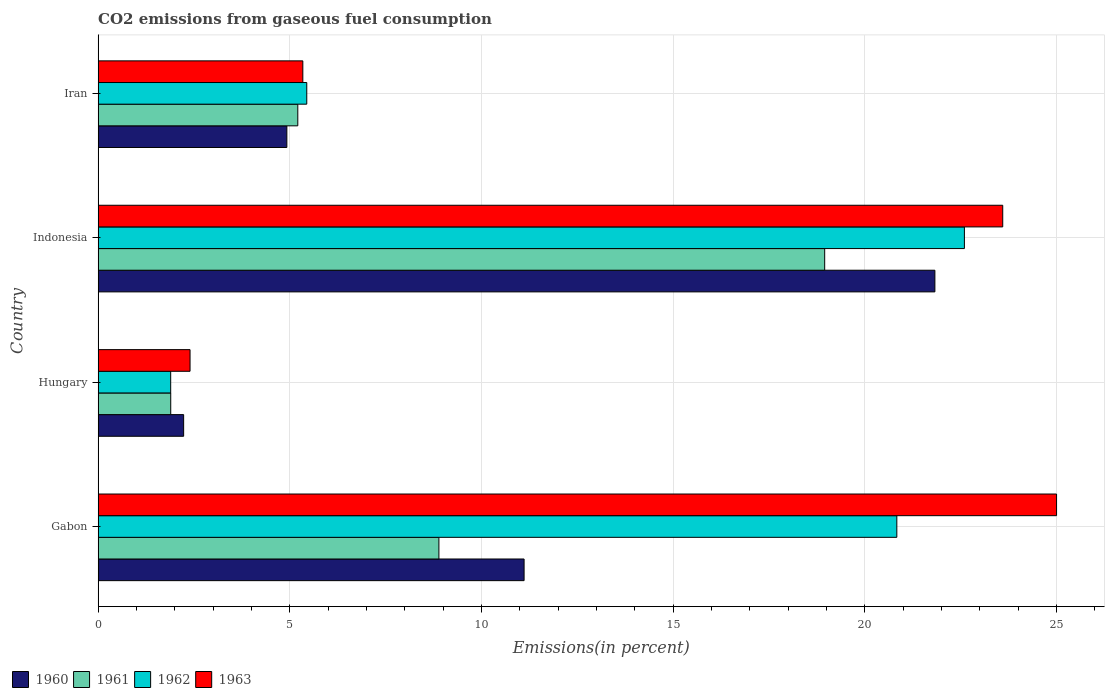How many different coloured bars are there?
Keep it short and to the point. 4. Are the number of bars per tick equal to the number of legend labels?
Your answer should be compact. Yes. Are the number of bars on each tick of the Y-axis equal?
Offer a very short reply. Yes. How many bars are there on the 4th tick from the top?
Your answer should be compact. 4. What is the label of the 3rd group of bars from the top?
Provide a short and direct response. Hungary. In how many cases, is the number of bars for a given country not equal to the number of legend labels?
Make the answer very short. 0. What is the total CO2 emitted in 1961 in Indonesia?
Provide a succinct answer. 18.95. Across all countries, what is the maximum total CO2 emitted in 1961?
Provide a short and direct response. 18.95. Across all countries, what is the minimum total CO2 emitted in 1963?
Make the answer very short. 2.4. In which country was the total CO2 emitted in 1961 maximum?
Provide a succinct answer. Indonesia. In which country was the total CO2 emitted in 1961 minimum?
Your response must be concise. Hungary. What is the total total CO2 emitted in 1962 in the graph?
Keep it short and to the point. 50.76. What is the difference between the total CO2 emitted in 1963 in Indonesia and that in Iran?
Your answer should be very brief. 18.26. What is the difference between the total CO2 emitted in 1961 in Hungary and the total CO2 emitted in 1962 in Iran?
Make the answer very short. -3.55. What is the average total CO2 emitted in 1960 per country?
Provide a short and direct response. 10.02. What is the difference between the total CO2 emitted in 1960 and total CO2 emitted in 1962 in Iran?
Give a very brief answer. -0.52. In how many countries, is the total CO2 emitted in 1960 greater than 1 %?
Make the answer very short. 4. What is the ratio of the total CO2 emitted in 1961 in Indonesia to that in Iran?
Offer a terse response. 3.64. Is the total CO2 emitted in 1961 in Hungary less than that in Iran?
Provide a short and direct response. Yes. What is the difference between the highest and the second highest total CO2 emitted in 1961?
Ensure brevity in your answer.  10.06. What is the difference between the highest and the lowest total CO2 emitted in 1963?
Your answer should be very brief. 22.6. Is the sum of the total CO2 emitted in 1960 in Indonesia and Iran greater than the maximum total CO2 emitted in 1961 across all countries?
Make the answer very short. Yes. Is it the case that in every country, the sum of the total CO2 emitted in 1963 and total CO2 emitted in 1962 is greater than the total CO2 emitted in 1961?
Your answer should be very brief. Yes. How many bars are there?
Provide a short and direct response. 16. Are all the bars in the graph horizontal?
Provide a succinct answer. Yes. How many countries are there in the graph?
Ensure brevity in your answer.  4. What is the difference between two consecutive major ticks on the X-axis?
Your response must be concise. 5. Are the values on the major ticks of X-axis written in scientific E-notation?
Your answer should be very brief. No. Does the graph contain any zero values?
Offer a terse response. No. What is the title of the graph?
Ensure brevity in your answer.  CO2 emissions from gaseous fuel consumption. Does "1990" appear as one of the legend labels in the graph?
Your answer should be very brief. No. What is the label or title of the X-axis?
Ensure brevity in your answer.  Emissions(in percent). What is the Emissions(in percent) in 1960 in Gabon?
Your answer should be very brief. 11.11. What is the Emissions(in percent) of 1961 in Gabon?
Offer a terse response. 8.89. What is the Emissions(in percent) in 1962 in Gabon?
Make the answer very short. 20.83. What is the Emissions(in percent) of 1960 in Hungary?
Offer a terse response. 2.23. What is the Emissions(in percent) of 1961 in Hungary?
Make the answer very short. 1.89. What is the Emissions(in percent) in 1962 in Hungary?
Provide a succinct answer. 1.89. What is the Emissions(in percent) of 1963 in Hungary?
Ensure brevity in your answer.  2.4. What is the Emissions(in percent) in 1960 in Indonesia?
Make the answer very short. 21.83. What is the Emissions(in percent) of 1961 in Indonesia?
Your response must be concise. 18.95. What is the Emissions(in percent) in 1962 in Indonesia?
Your answer should be very brief. 22.6. What is the Emissions(in percent) in 1963 in Indonesia?
Make the answer very short. 23.6. What is the Emissions(in percent) of 1960 in Iran?
Your response must be concise. 4.92. What is the Emissions(in percent) of 1961 in Iran?
Provide a succinct answer. 5.21. What is the Emissions(in percent) of 1962 in Iran?
Your response must be concise. 5.44. What is the Emissions(in percent) in 1963 in Iran?
Ensure brevity in your answer.  5.34. Across all countries, what is the maximum Emissions(in percent) in 1960?
Keep it short and to the point. 21.83. Across all countries, what is the maximum Emissions(in percent) of 1961?
Give a very brief answer. 18.95. Across all countries, what is the maximum Emissions(in percent) of 1962?
Provide a succinct answer. 22.6. Across all countries, what is the minimum Emissions(in percent) of 1960?
Make the answer very short. 2.23. Across all countries, what is the minimum Emissions(in percent) of 1961?
Ensure brevity in your answer.  1.89. Across all countries, what is the minimum Emissions(in percent) in 1962?
Provide a short and direct response. 1.89. Across all countries, what is the minimum Emissions(in percent) in 1963?
Your answer should be compact. 2.4. What is the total Emissions(in percent) of 1960 in the graph?
Your answer should be very brief. 40.09. What is the total Emissions(in percent) of 1961 in the graph?
Offer a terse response. 34.94. What is the total Emissions(in percent) in 1962 in the graph?
Give a very brief answer. 50.76. What is the total Emissions(in percent) of 1963 in the graph?
Provide a succinct answer. 56.33. What is the difference between the Emissions(in percent) in 1960 in Gabon and that in Hungary?
Provide a succinct answer. 8.88. What is the difference between the Emissions(in percent) of 1961 in Gabon and that in Hungary?
Your answer should be compact. 6.99. What is the difference between the Emissions(in percent) of 1962 in Gabon and that in Hungary?
Give a very brief answer. 18.94. What is the difference between the Emissions(in percent) of 1963 in Gabon and that in Hungary?
Your answer should be very brief. 22.6. What is the difference between the Emissions(in percent) of 1960 in Gabon and that in Indonesia?
Your answer should be very brief. -10.72. What is the difference between the Emissions(in percent) of 1961 in Gabon and that in Indonesia?
Your answer should be compact. -10.06. What is the difference between the Emissions(in percent) of 1962 in Gabon and that in Indonesia?
Your answer should be very brief. -1.76. What is the difference between the Emissions(in percent) of 1963 in Gabon and that in Indonesia?
Ensure brevity in your answer.  1.4. What is the difference between the Emissions(in percent) in 1960 in Gabon and that in Iran?
Ensure brevity in your answer.  6.19. What is the difference between the Emissions(in percent) of 1961 in Gabon and that in Iran?
Give a very brief answer. 3.68. What is the difference between the Emissions(in percent) of 1962 in Gabon and that in Iran?
Your answer should be compact. 15.39. What is the difference between the Emissions(in percent) of 1963 in Gabon and that in Iran?
Provide a short and direct response. 19.66. What is the difference between the Emissions(in percent) of 1960 in Hungary and that in Indonesia?
Offer a very short reply. -19.6. What is the difference between the Emissions(in percent) in 1961 in Hungary and that in Indonesia?
Offer a very short reply. -17.06. What is the difference between the Emissions(in percent) in 1962 in Hungary and that in Indonesia?
Your answer should be compact. -20.7. What is the difference between the Emissions(in percent) in 1963 in Hungary and that in Indonesia?
Make the answer very short. -21.2. What is the difference between the Emissions(in percent) in 1960 in Hungary and that in Iran?
Give a very brief answer. -2.69. What is the difference between the Emissions(in percent) of 1961 in Hungary and that in Iran?
Your answer should be compact. -3.31. What is the difference between the Emissions(in percent) in 1962 in Hungary and that in Iran?
Make the answer very short. -3.55. What is the difference between the Emissions(in percent) in 1963 in Hungary and that in Iran?
Keep it short and to the point. -2.94. What is the difference between the Emissions(in percent) in 1960 in Indonesia and that in Iran?
Give a very brief answer. 16.9. What is the difference between the Emissions(in percent) of 1961 in Indonesia and that in Iran?
Keep it short and to the point. 13.74. What is the difference between the Emissions(in percent) of 1962 in Indonesia and that in Iran?
Give a very brief answer. 17.15. What is the difference between the Emissions(in percent) in 1963 in Indonesia and that in Iran?
Ensure brevity in your answer.  18.26. What is the difference between the Emissions(in percent) in 1960 in Gabon and the Emissions(in percent) in 1961 in Hungary?
Offer a very short reply. 9.22. What is the difference between the Emissions(in percent) in 1960 in Gabon and the Emissions(in percent) in 1962 in Hungary?
Your answer should be compact. 9.22. What is the difference between the Emissions(in percent) in 1960 in Gabon and the Emissions(in percent) in 1963 in Hungary?
Give a very brief answer. 8.71. What is the difference between the Emissions(in percent) of 1961 in Gabon and the Emissions(in percent) of 1962 in Hungary?
Ensure brevity in your answer.  7. What is the difference between the Emissions(in percent) in 1961 in Gabon and the Emissions(in percent) in 1963 in Hungary?
Make the answer very short. 6.49. What is the difference between the Emissions(in percent) of 1962 in Gabon and the Emissions(in percent) of 1963 in Hungary?
Ensure brevity in your answer.  18.44. What is the difference between the Emissions(in percent) of 1960 in Gabon and the Emissions(in percent) of 1961 in Indonesia?
Keep it short and to the point. -7.84. What is the difference between the Emissions(in percent) in 1960 in Gabon and the Emissions(in percent) in 1962 in Indonesia?
Offer a very short reply. -11.48. What is the difference between the Emissions(in percent) of 1960 in Gabon and the Emissions(in percent) of 1963 in Indonesia?
Keep it short and to the point. -12.48. What is the difference between the Emissions(in percent) of 1961 in Gabon and the Emissions(in percent) of 1962 in Indonesia?
Ensure brevity in your answer.  -13.71. What is the difference between the Emissions(in percent) of 1961 in Gabon and the Emissions(in percent) of 1963 in Indonesia?
Offer a very short reply. -14.71. What is the difference between the Emissions(in percent) of 1962 in Gabon and the Emissions(in percent) of 1963 in Indonesia?
Provide a short and direct response. -2.76. What is the difference between the Emissions(in percent) in 1960 in Gabon and the Emissions(in percent) in 1961 in Iran?
Your answer should be very brief. 5.9. What is the difference between the Emissions(in percent) of 1960 in Gabon and the Emissions(in percent) of 1962 in Iran?
Ensure brevity in your answer.  5.67. What is the difference between the Emissions(in percent) of 1960 in Gabon and the Emissions(in percent) of 1963 in Iran?
Keep it short and to the point. 5.77. What is the difference between the Emissions(in percent) of 1961 in Gabon and the Emissions(in percent) of 1962 in Iran?
Your response must be concise. 3.45. What is the difference between the Emissions(in percent) of 1961 in Gabon and the Emissions(in percent) of 1963 in Iran?
Your response must be concise. 3.55. What is the difference between the Emissions(in percent) in 1962 in Gabon and the Emissions(in percent) in 1963 in Iran?
Provide a succinct answer. 15.49. What is the difference between the Emissions(in percent) of 1960 in Hungary and the Emissions(in percent) of 1961 in Indonesia?
Ensure brevity in your answer.  -16.72. What is the difference between the Emissions(in percent) in 1960 in Hungary and the Emissions(in percent) in 1962 in Indonesia?
Give a very brief answer. -20.37. What is the difference between the Emissions(in percent) in 1960 in Hungary and the Emissions(in percent) in 1963 in Indonesia?
Ensure brevity in your answer.  -21.36. What is the difference between the Emissions(in percent) in 1961 in Hungary and the Emissions(in percent) in 1962 in Indonesia?
Your response must be concise. -20.7. What is the difference between the Emissions(in percent) of 1961 in Hungary and the Emissions(in percent) of 1963 in Indonesia?
Provide a short and direct response. -21.7. What is the difference between the Emissions(in percent) of 1962 in Hungary and the Emissions(in percent) of 1963 in Indonesia?
Your answer should be compact. -21.7. What is the difference between the Emissions(in percent) of 1960 in Hungary and the Emissions(in percent) of 1961 in Iran?
Give a very brief answer. -2.98. What is the difference between the Emissions(in percent) in 1960 in Hungary and the Emissions(in percent) in 1962 in Iran?
Make the answer very short. -3.21. What is the difference between the Emissions(in percent) in 1960 in Hungary and the Emissions(in percent) in 1963 in Iran?
Provide a short and direct response. -3.11. What is the difference between the Emissions(in percent) in 1961 in Hungary and the Emissions(in percent) in 1962 in Iran?
Make the answer very short. -3.55. What is the difference between the Emissions(in percent) of 1961 in Hungary and the Emissions(in percent) of 1963 in Iran?
Your answer should be compact. -3.45. What is the difference between the Emissions(in percent) in 1962 in Hungary and the Emissions(in percent) in 1963 in Iran?
Make the answer very short. -3.45. What is the difference between the Emissions(in percent) in 1960 in Indonesia and the Emissions(in percent) in 1961 in Iran?
Offer a very short reply. 16.62. What is the difference between the Emissions(in percent) in 1960 in Indonesia and the Emissions(in percent) in 1962 in Iran?
Offer a very short reply. 16.38. What is the difference between the Emissions(in percent) of 1960 in Indonesia and the Emissions(in percent) of 1963 in Iran?
Keep it short and to the point. 16.49. What is the difference between the Emissions(in percent) in 1961 in Indonesia and the Emissions(in percent) in 1962 in Iran?
Your answer should be compact. 13.51. What is the difference between the Emissions(in percent) of 1961 in Indonesia and the Emissions(in percent) of 1963 in Iran?
Your response must be concise. 13.61. What is the difference between the Emissions(in percent) of 1962 in Indonesia and the Emissions(in percent) of 1963 in Iran?
Offer a very short reply. 17.26. What is the average Emissions(in percent) in 1960 per country?
Make the answer very short. 10.02. What is the average Emissions(in percent) of 1961 per country?
Offer a terse response. 8.74. What is the average Emissions(in percent) of 1962 per country?
Your answer should be compact. 12.69. What is the average Emissions(in percent) of 1963 per country?
Provide a short and direct response. 14.08. What is the difference between the Emissions(in percent) of 1960 and Emissions(in percent) of 1961 in Gabon?
Ensure brevity in your answer.  2.22. What is the difference between the Emissions(in percent) of 1960 and Emissions(in percent) of 1962 in Gabon?
Provide a succinct answer. -9.72. What is the difference between the Emissions(in percent) of 1960 and Emissions(in percent) of 1963 in Gabon?
Provide a succinct answer. -13.89. What is the difference between the Emissions(in percent) of 1961 and Emissions(in percent) of 1962 in Gabon?
Your answer should be compact. -11.94. What is the difference between the Emissions(in percent) of 1961 and Emissions(in percent) of 1963 in Gabon?
Your answer should be compact. -16.11. What is the difference between the Emissions(in percent) in 1962 and Emissions(in percent) in 1963 in Gabon?
Provide a succinct answer. -4.17. What is the difference between the Emissions(in percent) in 1960 and Emissions(in percent) in 1961 in Hungary?
Offer a very short reply. 0.34. What is the difference between the Emissions(in percent) of 1960 and Emissions(in percent) of 1962 in Hungary?
Give a very brief answer. 0.34. What is the difference between the Emissions(in percent) in 1960 and Emissions(in percent) in 1963 in Hungary?
Keep it short and to the point. -0.17. What is the difference between the Emissions(in percent) of 1961 and Emissions(in percent) of 1962 in Hungary?
Your answer should be compact. 0. What is the difference between the Emissions(in percent) of 1961 and Emissions(in percent) of 1963 in Hungary?
Your response must be concise. -0.5. What is the difference between the Emissions(in percent) in 1962 and Emissions(in percent) in 1963 in Hungary?
Ensure brevity in your answer.  -0.5. What is the difference between the Emissions(in percent) in 1960 and Emissions(in percent) in 1961 in Indonesia?
Make the answer very short. 2.87. What is the difference between the Emissions(in percent) of 1960 and Emissions(in percent) of 1962 in Indonesia?
Your answer should be very brief. -0.77. What is the difference between the Emissions(in percent) in 1960 and Emissions(in percent) in 1963 in Indonesia?
Ensure brevity in your answer.  -1.77. What is the difference between the Emissions(in percent) of 1961 and Emissions(in percent) of 1962 in Indonesia?
Your answer should be very brief. -3.64. What is the difference between the Emissions(in percent) of 1961 and Emissions(in percent) of 1963 in Indonesia?
Offer a very short reply. -4.64. What is the difference between the Emissions(in percent) in 1962 and Emissions(in percent) in 1963 in Indonesia?
Make the answer very short. -1. What is the difference between the Emissions(in percent) of 1960 and Emissions(in percent) of 1961 in Iran?
Keep it short and to the point. -0.29. What is the difference between the Emissions(in percent) of 1960 and Emissions(in percent) of 1962 in Iran?
Offer a very short reply. -0.52. What is the difference between the Emissions(in percent) of 1960 and Emissions(in percent) of 1963 in Iran?
Your answer should be very brief. -0.42. What is the difference between the Emissions(in percent) of 1961 and Emissions(in percent) of 1962 in Iran?
Provide a succinct answer. -0.23. What is the difference between the Emissions(in percent) in 1961 and Emissions(in percent) in 1963 in Iran?
Your answer should be compact. -0.13. What is the difference between the Emissions(in percent) of 1962 and Emissions(in percent) of 1963 in Iran?
Give a very brief answer. 0.1. What is the ratio of the Emissions(in percent) of 1960 in Gabon to that in Hungary?
Offer a very short reply. 4.98. What is the ratio of the Emissions(in percent) of 1961 in Gabon to that in Hungary?
Provide a short and direct response. 4.69. What is the ratio of the Emissions(in percent) in 1962 in Gabon to that in Hungary?
Give a very brief answer. 11.01. What is the ratio of the Emissions(in percent) of 1963 in Gabon to that in Hungary?
Make the answer very short. 10.43. What is the ratio of the Emissions(in percent) of 1960 in Gabon to that in Indonesia?
Make the answer very short. 0.51. What is the ratio of the Emissions(in percent) in 1961 in Gabon to that in Indonesia?
Your response must be concise. 0.47. What is the ratio of the Emissions(in percent) in 1962 in Gabon to that in Indonesia?
Provide a short and direct response. 0.92. What is the ratio of the Emissions(in percent) in 1963 in Gabon to that in Indonesia?
Your response must be concise. 1.06. What is the ratio of the Emissions(in percent) in 1960 in Gabon to that in Iran?
Offer a very short reply. 2.26. What is the ratio of the Emissions(in percent) of 1961 in Gabon to that in Iran?
Ensure brevity in your answer.  1.71. What is the ratio of the Emissions(in percent) in 1962 in Gabon to that in Iran?
Provide a succinct answer. 3.83. What is the ratio of the Emissions(in percent) of 1963 in Gabon to that in Iran?
Give a very brief answer. 4.68. What is the ratio of the Emissions(in percent) in 1960 in Hungary to that in Indonesia?
Keep it short and to the point. 0.1. What is the ratio of the Emissions(in percent) in 1961 in Hungary to that in Indonesia?
Offer a very short reply. 0.1. What is the ratio of the Emissions(in percent) in 1962 in Hungary to that in Indonesia?
Offer a terse response. 0.08. What is the ratio of the Emissions(in percent) in 1963 in Hungary to that in Indonesia?
Offer a very short reply. 0.1. What is the ratio of the Emissions(in percent) in 1960 in Hungary to that in Iran?
Ensure brevity in your answer.  0.45. What is the ratio of the Emissions(in percent) in 1961 in Hungary to that in Iran?
Offer a terse response. 0.36. What is the ratio of the Emissions(in percent) of 1962 in Hungary to that in Iran?
Provide a short and direct response. 0.35. What is the ratio of the Emissions(in percent) of 1963 in Hungary to that in Iran?
Offer a terse response. 0.45. What is the ratio of the Emissions(in percent) of 1960 in Indonesia to that in Iran?
Make the answer very short. 4.43. What is the ratio of the Emissions(in percent) in 1961 in Indonesia to that in Iran?
Your response must be concise. 3.64. What is the ratio of the Emissions(in percent) of 1962 in Indonesia to that in Iran?
Offer a very short reply. 4.15. What is the ratio of the Emissions(in percent) of 1963 in Indonesia to that in Iran?
Offer a very short reply. 4.42. What is the difference between the highest and the second highest Emissions(in percent) of 1960?
Your response must be concise. 10.72. What is the difference between the highest and the second highest Emissions(in percent) in 1961?
Offer a very short reply. 10.06. What is the difference between the highest and the second highest Emissions(in percent) in 1962?
Provide a succinct answer. 1.76. What is the difference between the highest and the second highest Emissions(in percent) of 1963?
Provide a succinct answer. 1.4. What is the difference between the highest and the lowest Emissions(in percent) of 1960?
Provide a short and direct response. 19.6. What is the difference between the highest and the lowest Emissions(in percent) in 1961?
Your answer should be compact. 17.06. What is the difference between the highest and the lowest Emissions(in percent) of 1962?
Make the answer very short. 20.7. What is the difference between the highest and the lowest Emissions(in percent) in 1963?
Offer a very short reply. 22.6. 